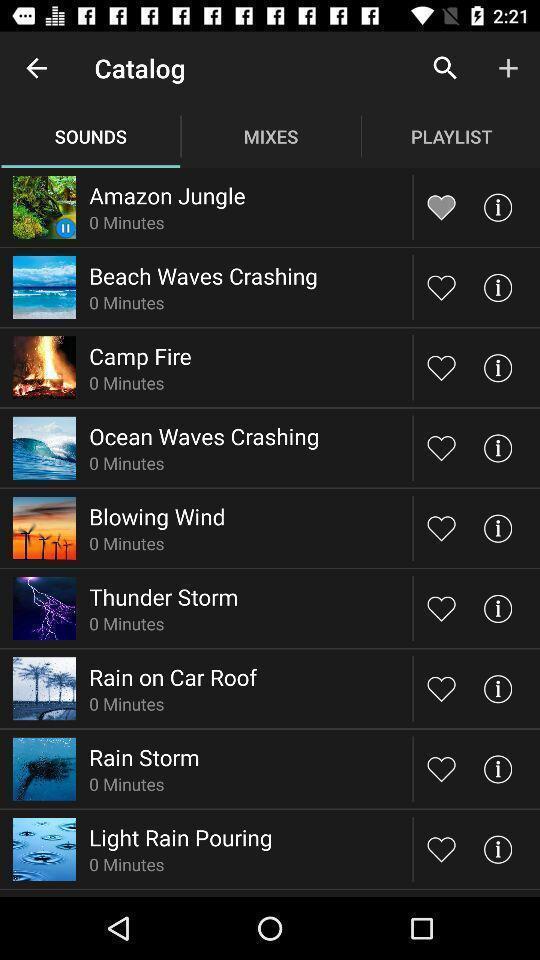Tell me what you see in this picture. Page listing different environmental audio files. 